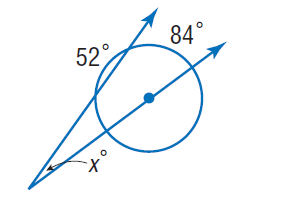Question: Find x.
Choices:
A. 20
B. 42
C. 52
D. 84
Answer with the letter. Answer: A 